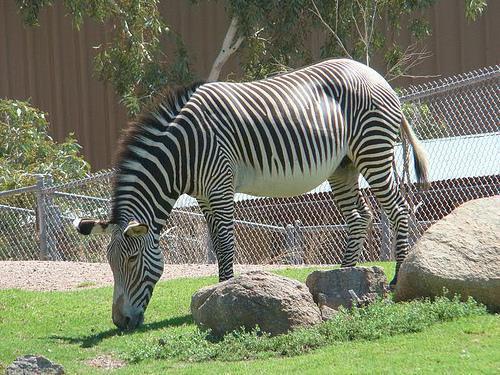How many zebras are in picture?
Give a very brief answer. 1. How many rocks are in photo?
Give a very brief answer. 4. 